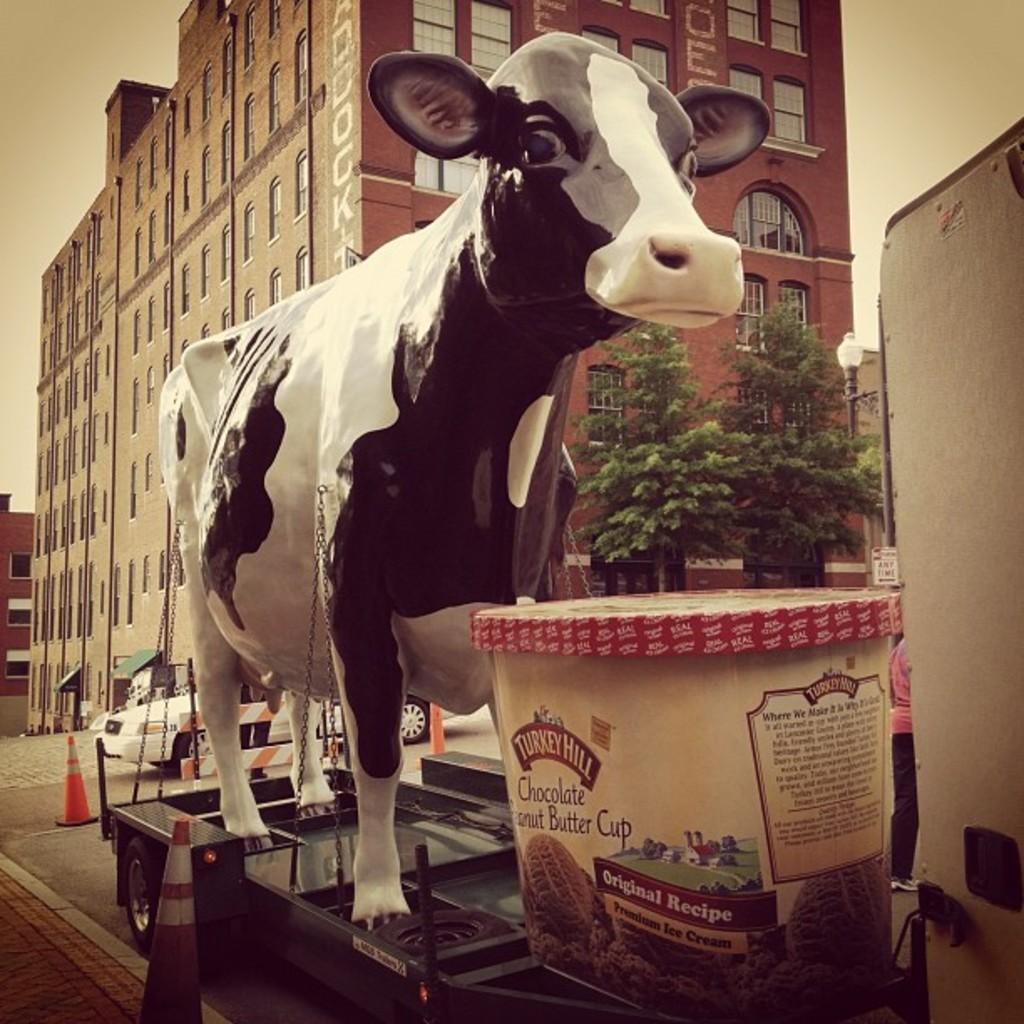Can you describe this image briefly? This image is taken outdoors. At the bottom of the image there is a road and a truck is parked on the road. In the middle of the image there is a toy cow and a cup on the truck. In the background there are a few buildings with walls, windows, doors and roofs. There are a few trees and a car is parked on the road. At the top of the image there is a sky. 